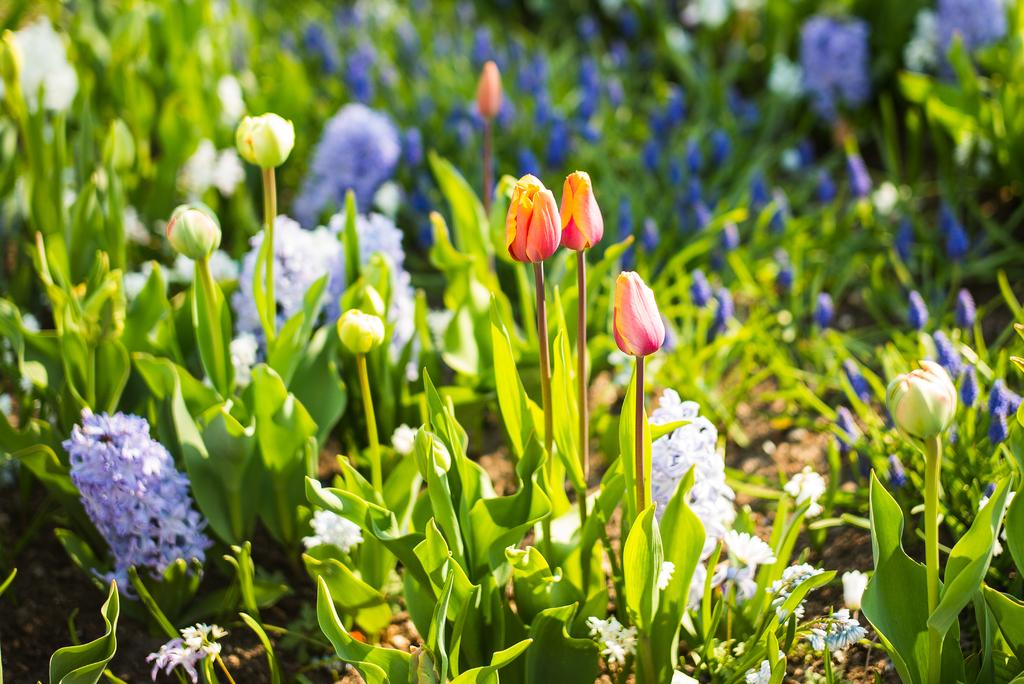What type of plants can be seen in the image? There are colorful flowers in the image. Can you describe the background of the image? The background of the image is blurry. What type of corn can be seen growing among the flowers in the image? There is no corn present in the image; it only features colorful flowers. 